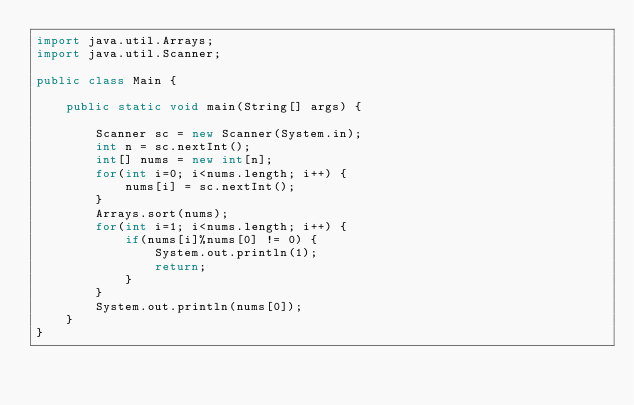Convert code to text. <code><loc_0><loc_0><loc_500><loc_500><_Java_>import java.util.Arrays;
import java.util.Scanner;

public class Main {

	public static void main(String[] args) {

		Scanner sc = new Scanner(System.in);
		int n = sc.nextInt();
		int[] nums = new int[n];
		for(int i=0; i<nums.length; i++) {
			nums[i] = sc.nextInt();
		}
		Arrays.sort(nums);
		for(int i=1; i<nums.length; i++) {
			if(nums[i]%nums[0] != 0) {
				System.out.println(1);
				return;
			}
		}
		System.out.println(nums[0]);
	}
}
</code> 